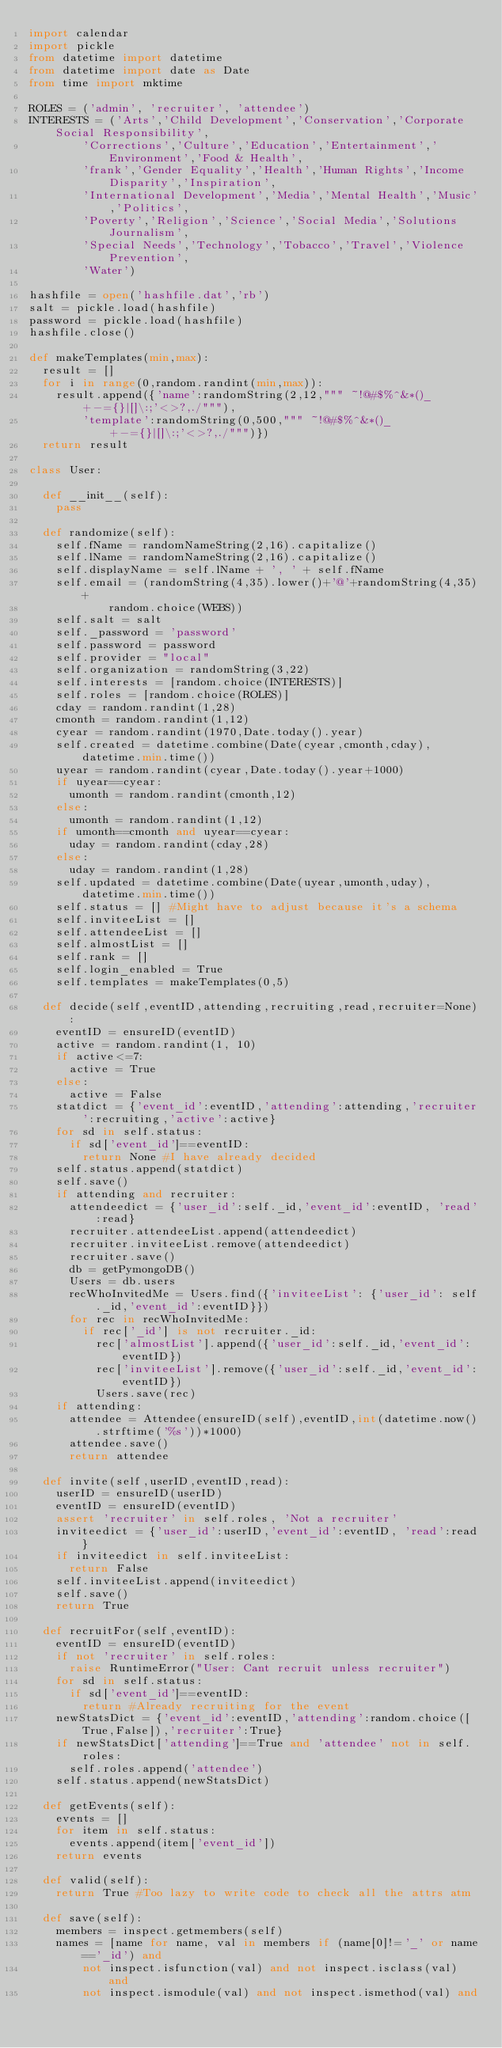<code> <loc_0><loc_0><loc_500><loc_500><_Python_>import calendar
import pickle
from datetime import datetime
from datetime import date as Date
from time import mktime

ROLES = ('admin', 'recruiter', 'attendee')
INTERESTS = ('Arts','Child Development','Conservation','Corporate Social Responsibility',
		'Corrections','Culture','Education','Entertainment','Environment','Food & Health',
		'frank','Gender Equality','Health','Human Rights','Income Disparity','Inspiration',
		'International Development','Media','Mental Health','Music','Politics',
		'Poverty','Religion','Science','Social Media','Solutions Journalism',
		'Special Needs','Technology','Tobacco','Travel','Violence Prevention',
		'Water')

hashfile = open('hashfile.dat','rb')
salt = pickle.load(hashfile)
password = pickle.load(hashfile)
hashfile.close()

def makeTemplates(min,max):
  result = []
  for i in range(0,random.randint(min,max)):
    result.append({'name':randomString(2,12,""" ~!@#$%^&*()_+-={}|[]\:;'<>?,./"""),
		'template':randomString(0,500,""" ~!@#$%^&*()_+-={}|[]\:;'<>?,./""")})
  return result

class User:

  def __init__(self):
    pass

  def randomize(self):
    self.fName = randomNameString(2,16).capitalize()
    self.lName = randomNameString(2,16).capitalize()
    self.displayName = self.lName + ', ' + self.fName
    self.email = (randomString(4,35).lower()+'@'+randomString(4,35)+
			random.choice(WEBS))
    self.salt = salt
    self._password = 'password'
    self.password = password
    self.provider = "local"
    self.organization = randomString(3,22)
    self.interests = [random.choice(INTERESTS)]
    self.roles = [random.choice(ROLES)]
    cday = random.randint(1,28)
    cmonth = random.randint(1,12)
    cyear = random.randint(1970,Date.today().year)
    self.created = datetime.combine(Date(cyear,cmonth,cday),datetime.min.time())
    uyear = random.randint(cyear,Date.today().year+1000)
    if uyear==cyear:
      umonth = random.randint(cmonth,12)
    else:
      umonth = random.randint(1,12)
    if umonth==cmonth and uyear==cyear:
      uday = random.randint(cday,28)
    else:
      uday = random.randint(1,28)
    self.updated = datetime.combine(Date(uyear,umonth,uday),datetime.min.time())
    self.status = [] #Might have to adjust because it's a schema
    self.inviteeList = []
    self.attendeeList = []
    self.almostList = []
    self.rank = []
    self.login_enabled = True
    self.templates = makeTemplates(0,5)

  def decide(self,eventID,attending,recruiting,read,recruiter=None):
    eventID = ensureID(eventID)
    active = random.randint(1, 10)
    if active<=7:
      active = True
    else:
      active = False
    statdict = {'event_id':eventID,'attending':attending,'recruiter':recruiting,'active':active}
    for sd in self.status:
      if sd['event_id']==eventID:
        return None #I have already decided
    self.status.append(statdict)
    self.save()
    if attending and recruiter:
      attendeedict = {'user_id':self._id,'event_id':eventID, 'read':read}
      recruiter.attendeeList.append(attendeedict)
      recruiter.inviteeList.remove(attendeedict)
      recruiter.save()
      db = getPymongoDB()
      Users = db.users
      recWhoInvitedMe = Users.find({'inviteeList': {'user_id': self._id,'event_id':eventID}})
      for rec in recWhoInvitedMe:
        if rec['_id'] is not recruiter._id:
          rec['almostList'].append({'user_id':self._id,'event_id':eventID})
          rec['inviteeList'].remove({'user_id':self._id,'event_id':eventID})
          Users.save(rec)
    if attending:
      attendee = Attendee(ensureID(self),eventID,int(datetime.now().strftime('%s'))*1000)
      attendee.save()
      return attendee

  def invite(self,userID,eventID,read):
    userID = ensureID(userID)
    eventID = ensureID(eventID)
    assert 'recruiter' in self.roles, 'Not a recruiter'
    inviteedict = {'user_id':userID,'event_id':eventID, 'read':read}
    if inviteedict in self.inviteeList:
      return False
    self.inviteeList.append(inviteedict)
    self.save()
    return True

  def recruitFor(self,eventID):
    eventID = ensureID(eventID)
    if not 'recruiter' in self.roles:
      raise RuntimeError("User: Cant recruit unless recruiter")
    for sd in self.status:
      if sd['event_id']==eventID:
        return #Already recruiting for the event
    newStatsDict = {'event_id':eventID,'attending':random.choice([True,False]),'recruiter':True}
    if newStatsDict['attending']==True and 'attendee' not in self.roles:
      self.roles.append('attendee')
    self.status.append(newStatsDict)

  def getEvents(self):
    events = []
    for item in self.status:
      events.append(item['event_id'])
    return events

  def valid(self):
    return True #Too lazy to write code to check all the attrs atm

  def save(self):
    members = inspect.getmembers(self)
    names = [name for name, val in members if (name[0]!='_' or name=='_id') and
		not inspect.isfunction(val) and not inspect.isclass(val) and
		not inspect.ismodule(val) and not inspect.ismethod(val) and</code> 